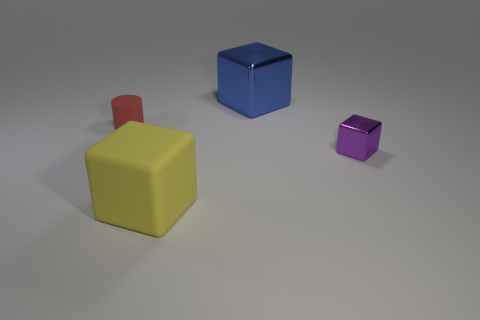Is the material of the thing that is in front of the small metallic thing the same as the small object in front of the tiny cylinder?
Provide a succinct answer. No. What shape is the thing that is both behind the big matte block and on the left side of the blue object?
Keep it short and to the point. Cylinder. The object that is in front of the rubber cylinder and to the right of the yellow cube is what color?
Provide a short and direct response. Purple. Is the number of small purple shiny things that are in front of the tiny shiny thing greater than the number of cylinders that are behind the large blue thing?
Your answer should be very brief. No. There is a small object that is in front of the tiny red cylinder; what color is it?
Your response must be concise. Purple. Is the shape of the matte object left of the yellow cube the same as the large thing that is left of the blue metallic block?
Your answer should be very brief. No. Are there any red objects of the same size as the yellow matte block?
Keep it short and to the point. No. There is a cube that is in front of the tiny metal block; what material is it?
Your answer should be compact. Rubber. Does the big object that is behind the tiny red rubber thing have the same material as the red cylinder?
Provide a succinct answer. No. Are any blue matte blocks visible?
Provide a succinct answer. No. 